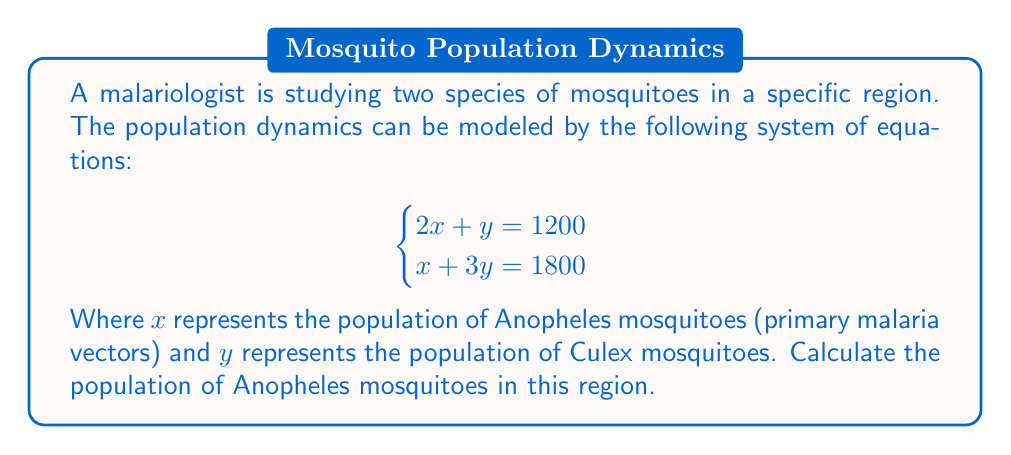Provide a solution to this math problem. To solve this system of equations, we can use the substitution method:

1) From the first equation, express $y$ in terms of $x$:
   $2x + y = 1200$
   $y = 1200 - 2x$

2) Substitute this expression for $y$ into the second equation:
   $x + 3(1200 - 2x) = 1800$

3) Simplify the equation:
   $x + 3600 - 6x = 1800$
   $-5x + 3600 = 1800$

4) Subtract 3600 from both sides:
   $-5x = -1800$

5) Divide both sides by -5:
   $x = 360$

6) Therefore, the population of Anopheles mosquitoes ($x$) is 360.

We can verify this by substituting $x = 360$ into the first equation to find $y$:
$2(360) + y = 1200$
$720 + y = 1200$
$y = 480$

These values satisfy both equations in the original system.
Answer: 360 Anopheles mosquitoes 